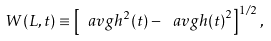<formula> <loc_0><loc_0><loc_500><loc_500>W ( L , t ) \equiv \left [ \ a v g { h ^ { 2 } ( t ) } - \ a v g { h ( t ) } ^ { 2 } \right ] ^ { 1 / 2 } ,</formula> 